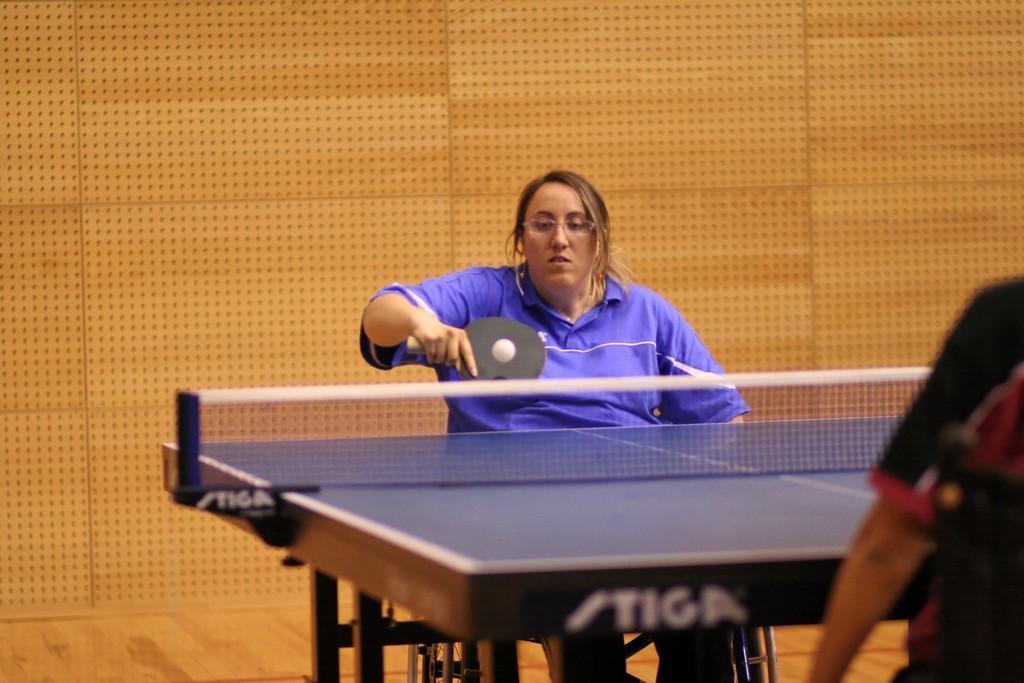Describe this image in one or two sentences. She is sitting in a chair. She is playing a table tennis. She is wearing a colorful blue shirt. On the right side we have another person. 